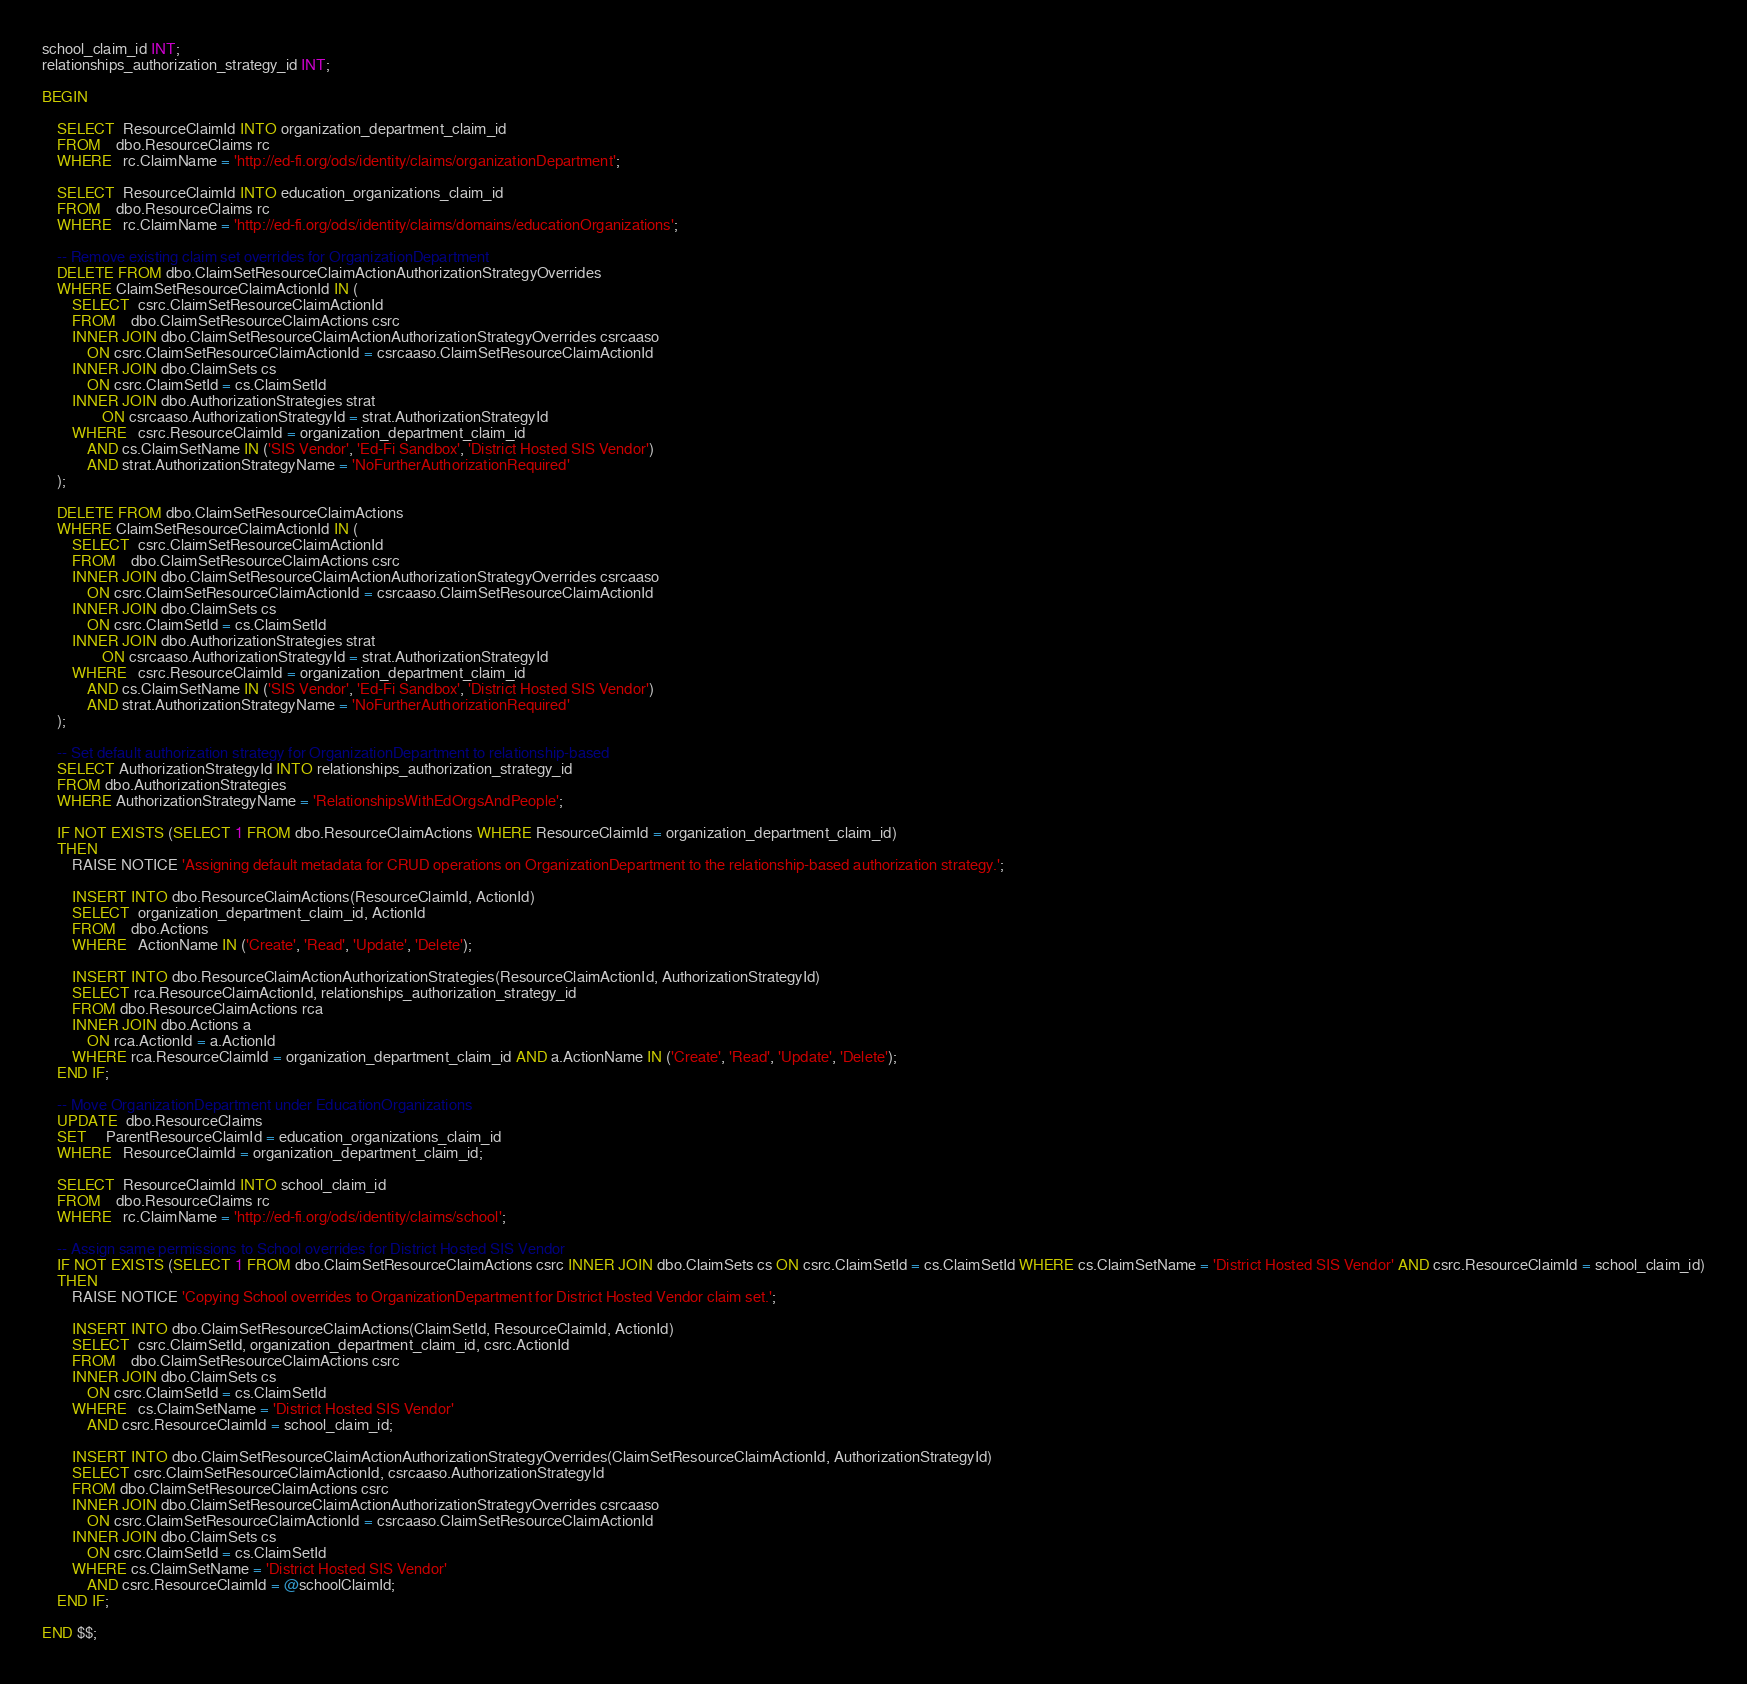Convert code to text. <code><loc_0><loc_0><loc_500><loc_500><_SQL_>school_claim_id INT;
relationships_authorization_strategy_id INT;

BEGIN

	SELECT  ResourceClaimId INTO organization_department_claim_id
	FROM    dbo.ResourceClaims rc
	WHERE   rc.ClaimName = 'http://ed-fi.org/ods/identity/claims/organizationDepartment';

	SELECT  ResourceClaimId INTO education_organizations_claim_id
	FROM    dbo.ResourceClaims rc
	WHERE   rc.ClaimName = 'http://ed-fi.org/ods/identity/claims/domains/educationOrganizations';

	-- Remove existing claim set overrides for OrganizationDepartment
	DELETE FROM dbo.ClaimSetResourceClaimActionAuthorizationStrategyOverrides
	WHERE ClaimSetResourceClaimActionId IN (
		SELECT  csrc.ClaimSetResourceClaimActionId
		FROM    dbo.ClaimSetResourceClaimActions csrc
		INNER JOIN dbo.ClaimSetResourceClaimActionAuthorizationStrategyOverrides csrcaaso
			ON csrc.ClaimSetResourceClaimActionId = csrcaaso.ClaimSetResourceClaimActionId
		INNER JOIN dbo.ClaimSets cs
			ON csrc.ClaimSetId = cs.ClaimSetId
		INNER JOIN dbo.AuthorizationStrategies strat
				ON csrcaaso.AuthorizationStrategyId = strat.AuthorizationStrategyId
		WHERE   csrc.ResourceClaimId = organization_department_claim_id
			AND cs.ClaimSetName IN ('SIS Vendor', 'Ed-Fi Sandbox', 'District Hosted SIS Vendor')
			AND strat.AuthorizationStrategyName = 'NoFurtherAuthorizationRequired'
	);
	
	DELETE FROM dbo.ClaimSetResourceClaimActions
	WHERE ClaimSetResourceClaimActionId IN (
		SELECT  csrc.ClaimSetResourceClaimActionId
		FROM    dbo.ClaimSetResourceClaimActions csrc
		INNER JOIN dbo.ClaimSetResourceClaimActionAuthorizationStrategyOverrides csrcaaso
			ON csrc.ClaimSetResourceClaimActionId = csrcaaso.ClaimSetResourceClaimActionId
		INNER JOIN dbo.ClaimSets cs
			ON csrc.ClaimSetId = cs.ClaimSetId
		INNER JOIN dbo.AuthorizationStrategies strat
				ON csrcaaso.AuthorizationStrategyId = strat.AuthorizationStrategyId
		WHERE   csrc.ResourceClaimId = organization_department_claim_id
			AND cs.ClaimSetName IN ('SIS Vendor', 'Ed-Fi Sandbox', 'District Hosted SIS Vendor')
			AND strat.AuthorizationStrategyName = 'NoFurtherAuthorizationRequired'
	);

	-- Set default authorization strategy for OrganizationDepartment to relationship-based
	SELECT AuthorizationStrategyId INTO relationships_authorization_strategy_id
	FROM dbo.AuthorizationStrategies
	WHERE AuthorizationStrategyName = 'RelationshipsWithEdOrgsAndPeople';

	IF NOT EXISTS (SELECT 1 FROM dbo.ResourceClaimActions WHERE ResourceClaimId = organization_department_claim_id)
	THEN
		RAISE NOTICE 'Assigning default metadata for CRUD operations on OrganizationDepartment to the relationship-based authorization strategy.';

		INSERT INTO dbo.ResourceClaimActions(ResourceClaimId, ActionId)
		SELECT  organization_department_claim_id, ActionId
		FROM    dbo.Actions
		WHERE   ActionName IN ('Create', 'Read', 'Update', 'Delete');
		
		INSERT INTO dbo.ResourceClaimActionAuthorizationStrategies(ResourceClaimActionId, AuthorizationStrategyId)
		SELECT rca.ResourceClaimActionId, relationships_authorization_strategy_id
		FROM dbo.ResourceClaimActions rca
		INNER JOIN dbo.Actions a
			ON rca.ActionId = a.ActionId
		WHERE rca.ResourceClaimId = organization_department_claim_id AND a.ActionName IN ('Create', 'Read', 'Update', 'Delete');
	END IF;

	-- Move OrganizationDepartment under EducationOrganizations
	UPDATE  dbo.ResourceClaims
	SET     ParentResourceClaimId = education_organizations_claim_id
	WHERE   ResourceClaimId = organization_department_claim_id;

	SELECT  ResourceClaimId INTO school_claim_id
	FROM    dbo.ResourceClaims rc
	WHERE   rc.ClaimName = 'http://ed-fi.org/ods/identity/claims/school';

	-- Assign same permissions to School overrides for District Hosted SIS Vendor
	IF NOT EXISTS (SELECT 1 FROM dbo.ClaimSetResourceClaimActions csrc INNER JOIN dbo.ClaimSets cs ON csrc.ClaimSetId = cs.ClaimSetId WHERE cs.ClaimSetName = 'District Hosted SIS Vendor' AND csrc.ResourceClaimId = school_claim_id)
	THEN
		RAISE NOTICE 'Copying School overrides to OrganizationDepartment for District Hosted Vendor claim set.';

		INSERT INTO dbo.ClaimSetResourceClaimActions(ClaimSetId, ResourceClaimId, ActionId)
		SELECT  csrc.ClaimSetId, organization_department_claim_id, csrc.ActionId
		FROM    dbo.ClaimSetResourceClaimActions csrc
		INNER JOIN dbo.ClaimSets cs
			ON csrc.ClaimSetId = cs.ClaimSetId
		WHERE   cs.ClaimSetName = 'District Hosted SIS Vendor'
			AND csrc.ResourceClaimId = school_claim_id;
			
		INSERT INTO dbo.ClaimSetResourceClaimActionAuthorizationStrategyOverrides(ClaimSetResourceClaimActionId, AuthorizationStrategyId)
		SELECT csrc.ClaimSetResourceClaimActionId, csrcaaso.AuthorizationStrategyId
		FROM dbo.ClaimSetResourceClaimActions csrc
		INNER JOIN dbo.ClaimSetResourceClaimActionAuthorizationStrategyOverrides csrcaaso
			ON csrc.ClaimSetResourceClaimActionId = csrcaaso.ClaimSetResourceClaimActionId
		INNER JOIN dbo.ClaimSets cs
			ON csrc.ClaimSetId = cs.ClaimSetId
		WHERE cs.ClaimSetName = 'District Hosted SIS Vendor'
			AND csrc.ResourceClaimId = @schoolClaimId;
	END IF;

END $$;
</code> 